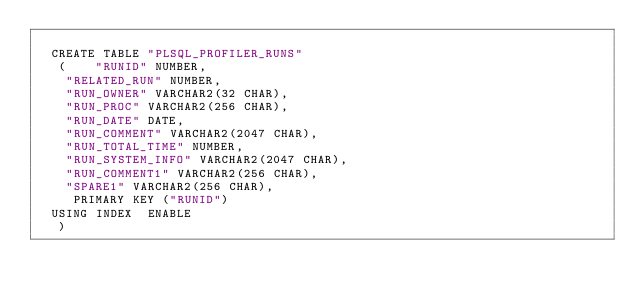Convert code to text. <code><loc_0><loc_0><loc_500><loc_500><_SQL_>
  CREATE TABLE "PLSQL_PROFILER_RUNS" 
   (	"RUNID" NUMBER, 
	"RELATED_RUN" NUMBER, 
	"RUN_OWNER" VARCHAR2(32 CHAR), 
	"RUN_PROC" VARCHAR2(256 CHAR), 
	"RUN_DATE" DATE, 
	"RUN_COMMENT" VARCHAR2(2047 CHAR), 
	"RUN_TOTAL_TIME" NUMBER, 
	"RUN_SYSTEM_INFO" VARCHAR2(2047 CHAR), 
	"RUN_COMMENT1" VARCHAR2(256 CHAR), 
	"SPARE1" VARCHAR2(256 CHAR), 
	 PRIMARY KEY ("RUNID")
  USING INDEX  ENABLE
   ) </code> 